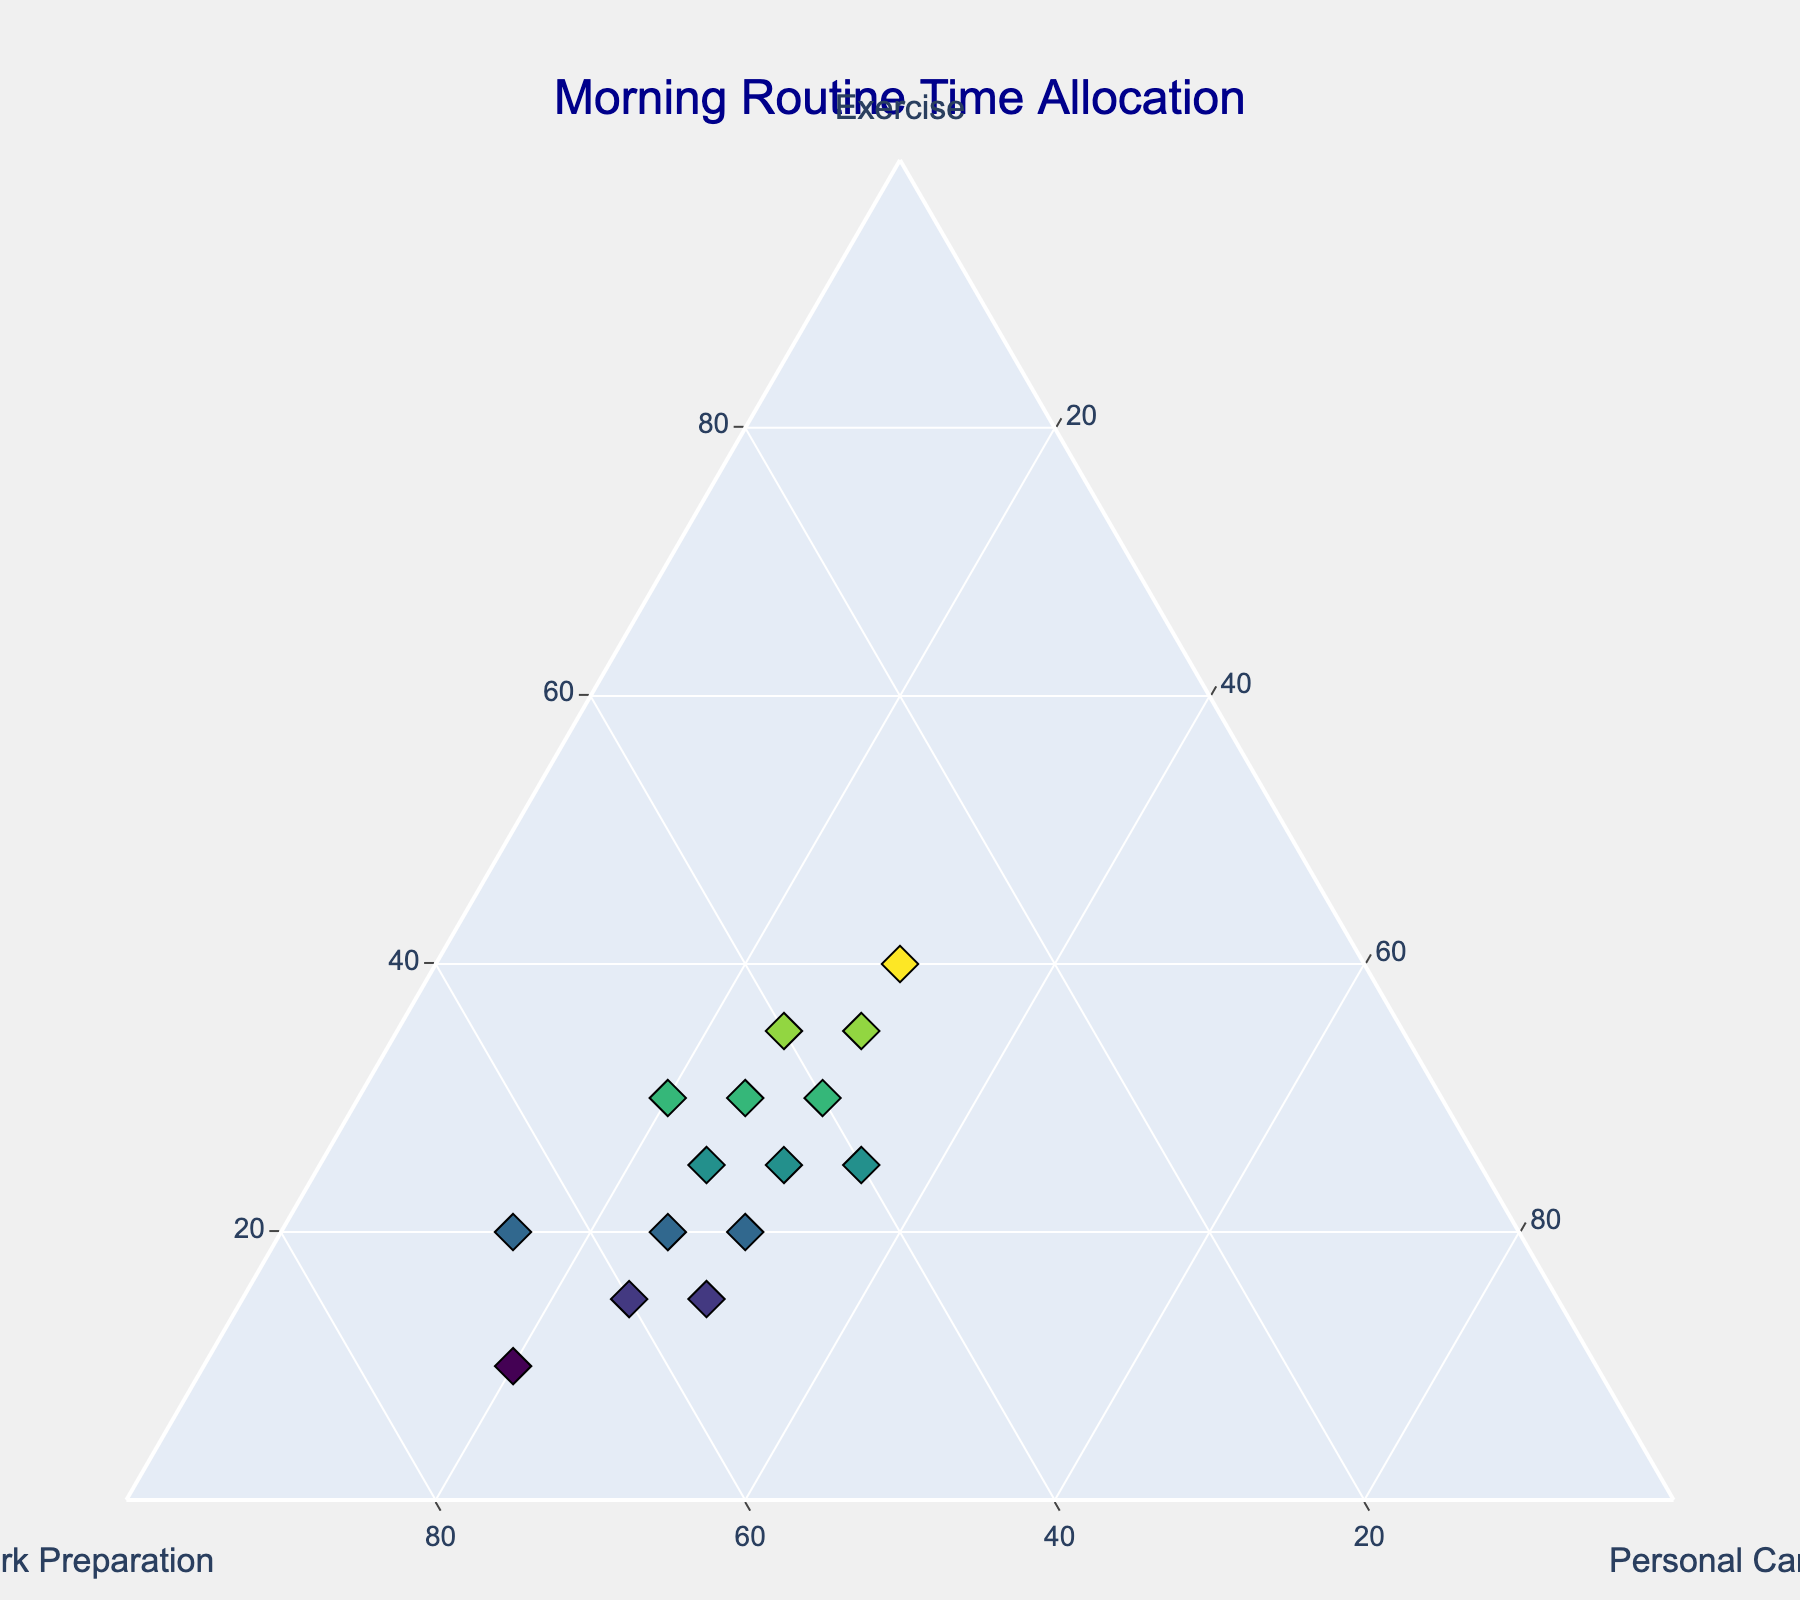How many data points are in the figure? Count the points on the plot or refer to the number of rows in the provided dataset.
Answer: 15 What is the range of values allocated to Work Preparation? Identify the minimum and maximum values in the 'Work Preparation' axis. Minimum is 30% and the maximum is 70%.
Answer: 30% to 70% Which section has the least amount of variability in time allocation? Compare the spread (range) in the values of Exercise, Work Preparation, and Personal Care by visually examining the clustering of data points along each axis. The 'Personal Care' values mostly range from 15% to 35%, showing relatively lesser variability.
Answer: Personal Care What is the sum of the percentages for the individual with the highest exercise time allocation? Look for the data point with exercise at 40%. Sum the values of Exercise, Work Preparation, and Personal Care for this point: 40% + 30% + 30%. Summing them equals 100%, conveying a balanced time allocation.
Answer: 100% Which combination of activities results in an individual spending equal time on Exercise and Personal Care? Find a data point where Exercise is equal to Personal Care, which is 25%, and Work Preparation constitutes the remaining 50%.
Answer: Exercise: 25%, Personal Care: 25% What is the difference in Work Preparation time allocation between the individual with the highest and lowest Exercise time allocation? Identify the highest exercise time (40%) and its corresponding work preparation (30%), then find the lowest exercise time (10%) and its corresponding work preparation (70%). The difference is 70% - 30%.
Answer: 40% How many individuals spend exactly 30% of their time on Exercise? Count the data points where Exercise = 30%. Those are 4 points: (30,40,30), (30,45,25), (30,50,20), (30,45,30).
Answer: 4 What is the average time spent on Personal Care? Sum the 'Personal Care' percentages and divide by the number of data points, averaging the values ((30+25+30+30+20+30+25+25+30+25+30+15+35+20+25)/15 ≈ 26.3%).
Answer: 26.3% Which axis shows the highest connectivity of data points indicating comparable time allocations? Examine which axis exhibits the densest clustering of data points across relatively narrow intervals. 'Work Preparation' shows points ranging from 30% to 70%, indicating the highest variability.
Answer: Work Preparation What is the relationship between Exercise and Work Preparation to maintain Personal Care at 25%? Examine datapoints where Personal Care = 25%, calculating each point's Exercise and Work Preparation fractions, e.g., (25,50,25), (30,45,25), totaling near balanced mutual adjustments maintaining Personal Care at 25%.
Answer: Their values adjust correspondingly to maintain constant Personal Care at 25% 